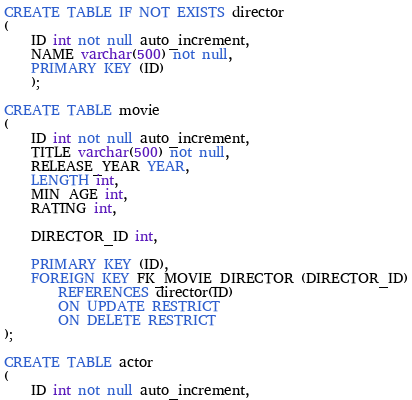Convert code to text. <code><loc_0><loc_0><loc_500><loc_500><_SQL_>CREATE TABLE IF NOT EXISTS director
(
	ID int not null auto_increment,
	NAME varchar(500) not null,
	PRIMARY KEY (ID)
	);

CREATE TABLE movie
(
	ID int not null auto_increment,
	TITLE varchar(500) not null,
	RELEASE_YEAR YEAR,
	LENGTH int,
	MIN_AGE int,
	RATING int,

	DIRECTOR_ID int,

	PRIMARY KEY (ID),
	FOREIGN KEY FK_MOVIE_DIRECTOR (DIRECTOR_ID)
		REFERENCES director(ID)
		ON UPDATE RESTRICT
		ON DELETE RESTRICT
);

CREATE TABLE actor
(
	ID int not null auto_increment,</code> 